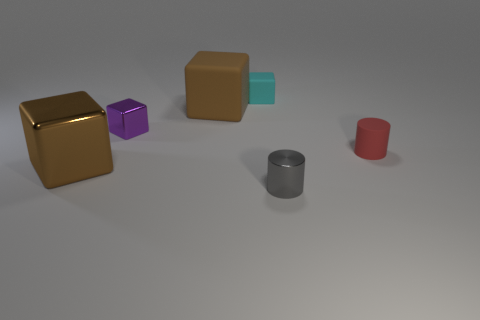Subtract 2 cubes. How many cubes are left? 2 Subtract all tiny purple metallic blocks. How many blocks are left? 3 Add 3 small purple metal blocks. How many objects exist? 9 Subtract all red cubes. Subtract all green spheres. How many cubes are left? 4 Subtract all cubes. How many objects are left? 2 Add 6 large cyan metallic objects. How many large cyan metallic objects exist? 6 Subtract 0 blue balls. How many objects are left? 6 Subtract all tiny cyan rubber blocks. Subtract all tiny red rubber cylinders. How many objects are left? 4 Add 3 tiny cyan cubes. How many tiny cyan cubes are left? 4 